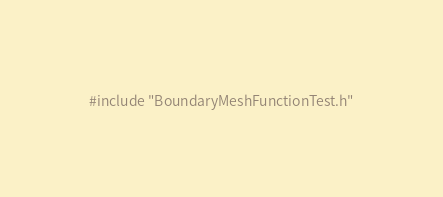Convert code to text. <code><loc_0><loc_0><loc_500><loc_500><_Cuda_>#include "BoundaryMeshFunctionTest.h"</code> 